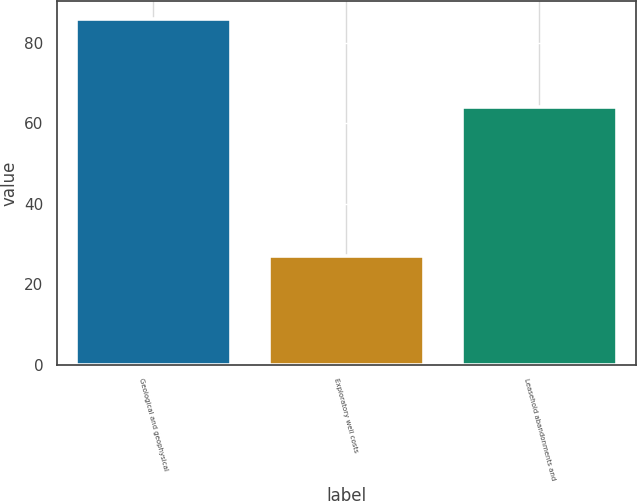Convert chart. <chart><loc_0><loc_0><loc_500><loc_500><bar_chart><fcel>Geological and geophysical<fcel>Exploratory well costs<fcel>Leasehold abandonments and<nl><fcel>86<fcel>27<fcel>64<nl></chart> 